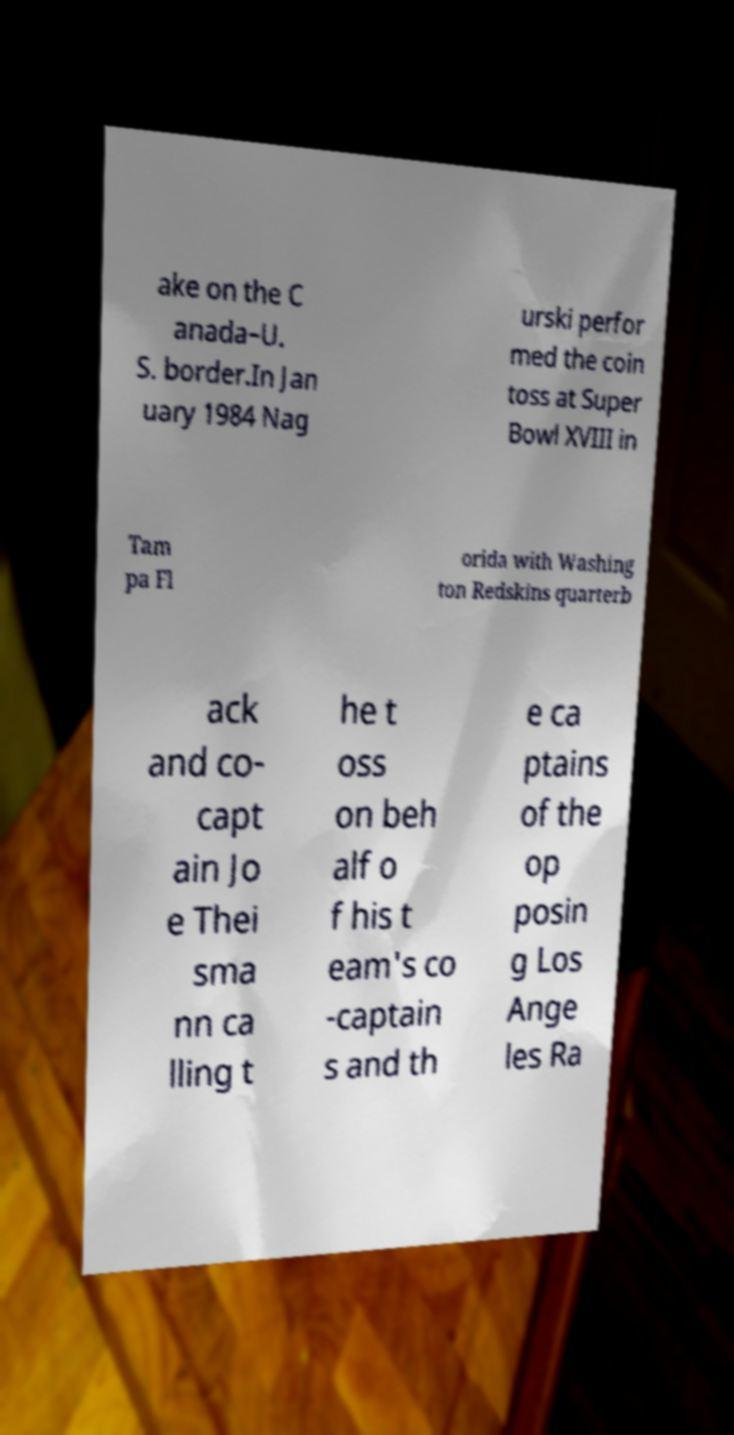Please identify and transcribe the text found in this image. ake on the C anada–U. S. border.In Jan uary 1984 Nag urski perfor med the coin toss at Super Bowl XVIII in Tam pa Fl orida with Washing ton Redskins quarterb ack and co- capt ain Jo e Thei sma nn ca lling t he t oss on beh alf o f his t eam's co -captain s and th e ca ptains of the op posin g Los Ange les Ra 